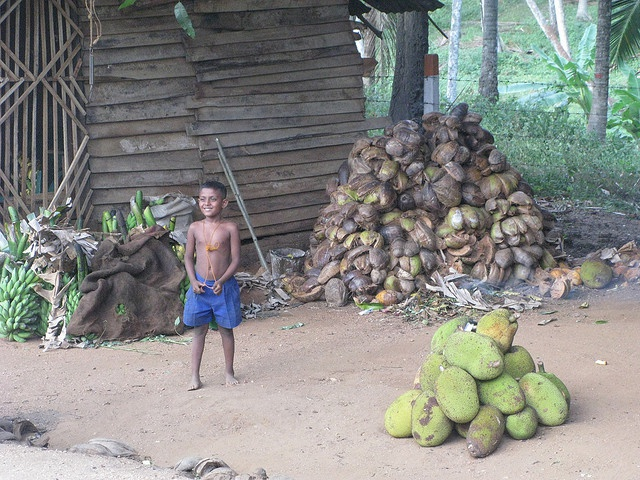Describe the objects in this image and their specific colors. I can see people in black, darkgray, gray, and pink tones, banana in black, teal, green, lightgreen, and darkgray tones, and banana in black and teal tones in this image. 